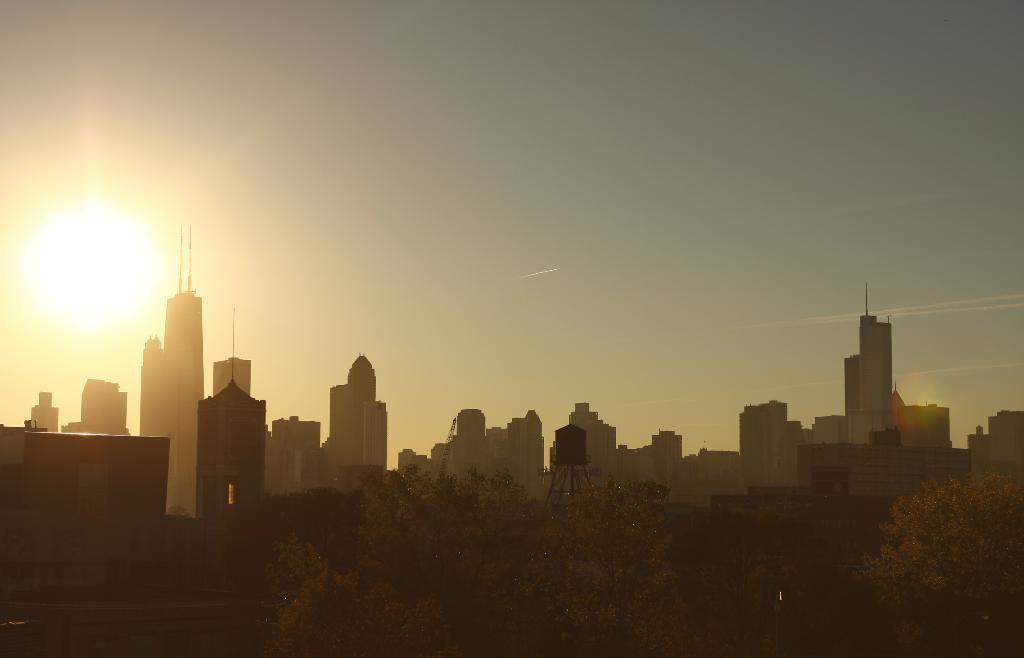What structures are located in the middle of the image? There are buildings in the middle of the image. What type of vegetation is on the right side of the image? There are trees on the right side of the image. What celestial body is visible in the sky on the left side of the image? The sun is visible in the sky on the left side of the image. How many stamps are on the tree on the right side of the image? There are no stamps present on the tree in the image. What type of lift can be seen in the image? There is no lift present in the image. 